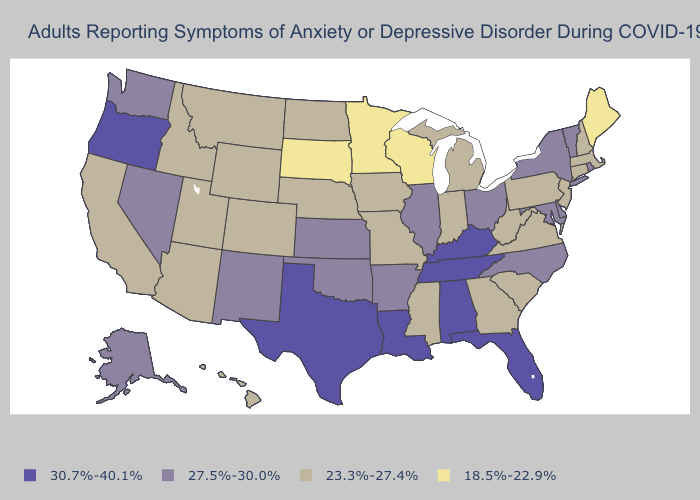What is the value of Georgia?
Keep it brief. 23.3%-27.4%. Which states have the highest value in the USA?
Be succinct. Alabama, Florida, Kentucky, Louisiana, Oregon, Tennessee, Texas. Which states have the lowest value in the USA?
Concise answer only. Maine, Minnesota, South Dakota, Wisconsin. Which states have the lowest value in the MidWest?
Answer briefly. Minnesota, South Dakota, Wisconsin. What is the value of Arizona?
Answer briefly. 23.3%-27.4%. Does Utah have the same value as Minnesota?
Concise answer only. No. What is the value of Michigan?
Be succinct. 23.3%-27.4%. What is the value of Oklahoma?
Short answer required. 27.5%-30.0%. How many symbols are there in the legend?
Give a very brief answer. 4. Which states have the lowest value in the Northeast?
Quick response, please. Maine. Does Tennessee have the lowest value in the USA?
Write a very short answer. No. Name the states that have a value in the range 18.5%-22.9%?
Give a very brief answer. Maine, Minnesota, South Dakota, Wisconsin. What is the value of Oregon?
Give a very brief answer. 30.7%-40.1%. What is the value of West Virginia?
Answer briefly. 23.3%-27.4%. Name the states that have a value in the range 30.7%-40.1%?
Be succinct. Alabama, Florida, Kentucky, Louisiana, Oregon, Tennessee, Texas. 